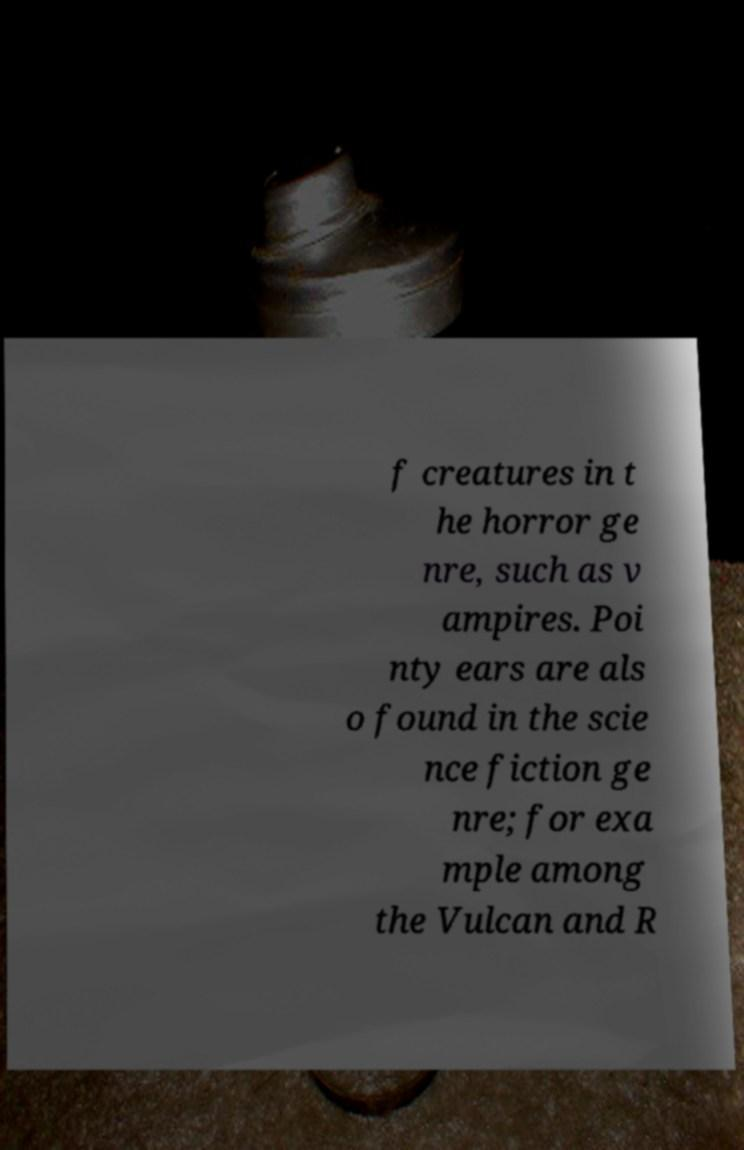For documentation purposes, I need the text within this image transcribed. Could you provide that? f creatures in t he horror ge nre, such as v ampires. Poi nty ears are als o found in the scie nce fiction ge nre; for exa mple among the Vulcan and R 